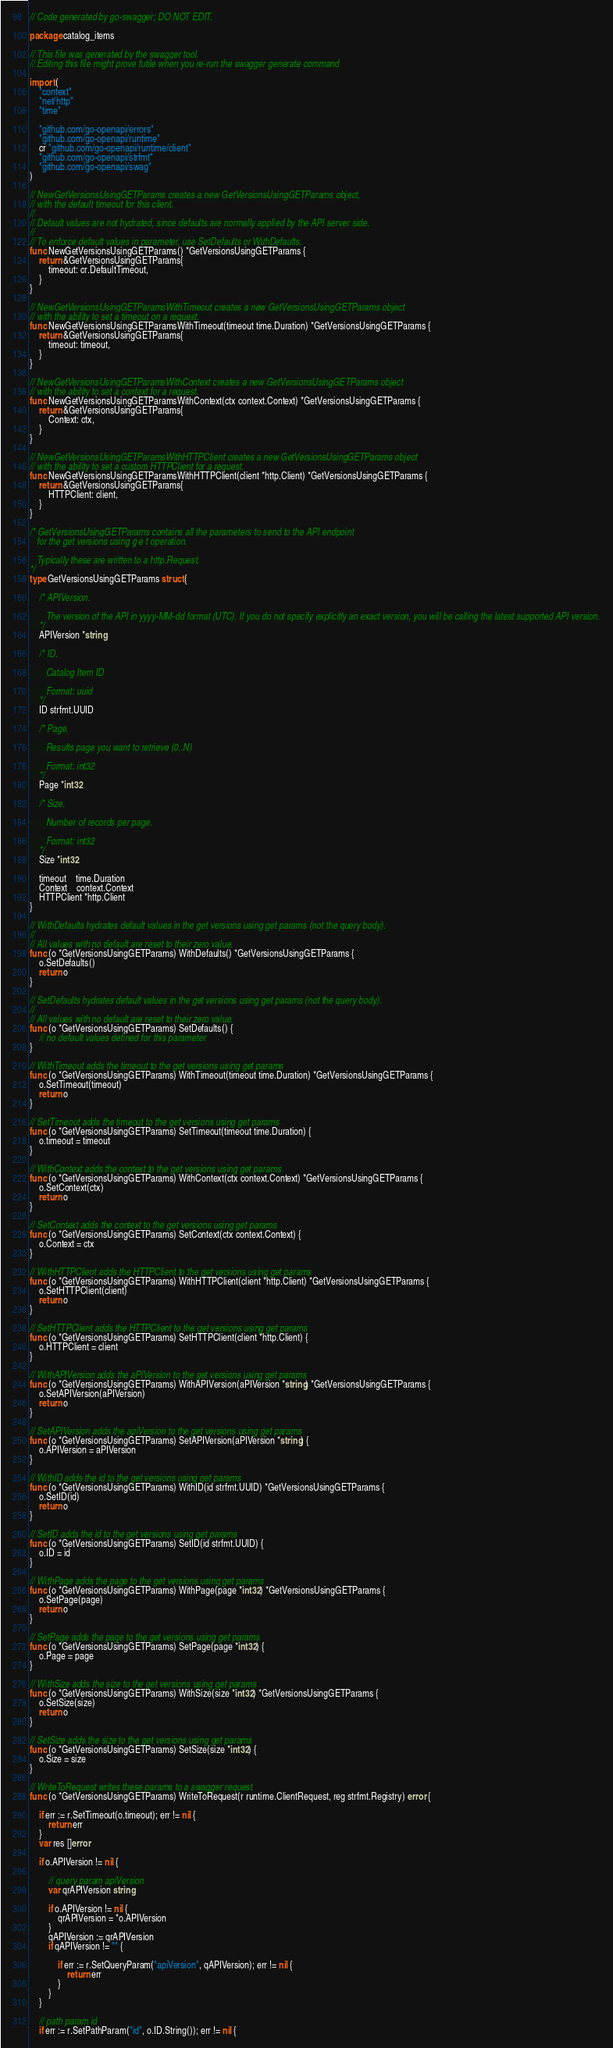<code> <loc_0><loc_0><loc_500><loc_500><_Go_>// Code generated by go-swagger; DO NOT EDIT.

package catalog_items

// This file was generated by the swagger tool.
// Editing this file might prove futile when you re-run the swagger generate command

import (
	"context"
	"net/http"
	"time"

	"github.com/go-openapi/errors"
	"github.com/go-openapi/runtime"
	cr "github.com/go-openapi/runtime/client"
	"github.com/go-openapi/strfmt"
	"github.com/go-openapi/swag"
)

// NewGetVersionsUsingGETParams creates a new GetVersionsUsingGETParams object,
// with the default timeout for this client.
//
// Default values are not hydrated, since defaults are normally applied by the API server side.
//
// To enforce default values in parameter, use SetDefaults or WithDefaults.
func NewGetVersionsUsingGETParams() *GetVersionsUsingGETParams {
	return &GetVersionsUsingGETParams{
		timeout: cr.DefaultTimeout,
	}
}

// NewGetVersionsUsingGETParamsWithTimeout creates a new GetVersionsUsingGETParams object
// with the ability to set a timeout on a request.
func NewGetVersionsUsingGETParamsWithTimeout(timeout time.Duration) *GetVersionsUsingGETParams {
	return &GetVersionsUsingGETParams{
		timeout: timeout,
	}
}

// NewGetVersionsUsingGETParamsWithContext creates a new GetVersionsUsingGETParams object
// with the ability to set a context for a request.
func NewGetVersionsUsingGETParamsWithContext(ctx context.Context) *GetVersionsUsingGETParams {
	return &GetVersionsUsingGETParams{
		Context: ctx,
	}
}

// NewGetVersionsUsingGETParamsWithHTTPClient creates a new GetVersionsUsingGETParams object
// with the ability to set a custom HTTPClient for a request.
func NewGetVersionsUsingGETParamsWithHTTPClient(client *http.Client) *GetVersionsUsingGETParams {
	return &GetVersionsUsingGETParams{
		HTTPClient: client,
	}
}

/* GetVersionsUsingGETParams contains all the parameters to send to the API endpoint
   for the get versions using g e t operation.

   Typically these are written to a http.Request.
*/
type GetVersionsUsingGETParams struct {

	/* APIVersion.

	   The version of the API in yyyy-MM-dd format (UTC). If you do not specify explicitly an exact version, you will be calling the latest supported API version.
	*/
	APIVersion *string

	/* ID.

	   Catalog Item ID

	   Format: uuid
	*/
	ID strfmt.UUID

	/* Page.

	   Results page you want to retrieve (0..N)

	   Format: int32
	*/
	Page *int32

	/* Size.

	   Number of records per page.

	   Format: int32
	*/
	Size *int32

	timeout    time.Duration
	Context    context.Context
	HTTPClient *http.Client
}

// WithDefaults hydrates default values in the get versions using get params (not the query body).
//
// All values with no default are reset to their zero value.
func (o *GetVersionsUsingGETParams) WithDefaults() *GetVersionsUsingGETParams {
	o.SetDefaults()
	return o
}

// SetDefaults hydrates default values in the get versions using get params (not the query body).
//
// All values with no default are reset to their zero value.
func (o *GetVersionsUsingGETParams) SetDefaults() {
	// no default values defined for this parameter
}

// WithTimeout adds the timeout to the get versions using get params
func (o *GetVersionsUsingGETParams) WithTimeout(timeout time.Duration) *GetVersionsUsingGETParams {
	o.SetTimeout(timeout)
	return o
}

// SetTimeout adds the timeout to the get versions using get params
func (o *GetVersionsUsingGETParams) SetTimeout(timeout time.Duration) {
	o.timeout = timeout
}

// WithContext adds the context to the get versions using get params
func (o *GetVersionsUsingGETParams) WithContext(ctx context.Context) *GetVersionsUsingGETParams {
	o.SetContext(ctx)
	return o
}

// SetContext adds the context to the get versions using get params
func (o *GetVersionsUsingGETParams) SetContext(ctx context.Context) {
	o.Context = ctx
}

// WithHTTPClient adds the HTTPClient to the get versions using get params
func (o *GetVersionsUsingGETParams) WithHTTPClient(client *http.Client) *GetVersionsUsingGETParams {
	o.SetHTTPClient(client)
	return o
}

// SetHTTPClient adds the HTTPClient to the get versions using get params
func (o *GetVersionsUsingGETParams) SetHTTPClient(client *http.Client) {
	o.HTTPClient = client
}

// WithAPIVersion adds the aPIVersion to the get versions using get params
func (o *GetVersionsUsingGETParams) WithAPIVersion(aPIVersion *string) *GetVersionsUsingGETParams {
	o.SetAPIVersion(aPIVersion)
	return o
}

// SetAPIVersion adds the apiVersion to the get versions using get params
func (o *GetVersionsUsingGETParams) SetAPIVersion(aPIVersion *string) {
	o.APIVersion = aPIVersion
}

// WithID adds the id to the get versions using get params
func (o *GetVersionsUsingGETParams) WithID(id strfmt.UUID) *GetVersionsUsingGETParams {
	o.SetID(id)
	return o
}

// SetID adds the id to the get versions using get params
func (o *GetVersionsUsingGETParams) SetID(id strfmt.UUID) {
	o.ID = id
}

// WithPage adds the page to the get versions using get params
func (o *GetVersionsUsingGETParams) WithPage(page *int32) *GetVersionsUsingGETParams {
	o.SetPage(page)
	return o
}

// SetPage adds the page to the get versions using get params
func (o *GetVersionsUsingGETParams) SetPage(page *int32) {
	o.Page = page
}

// WithSize adds the size to the get versions using get params
func (o *GetVersionsUsingGETParams) WithSize(size *int32) *GetVersionsUsingGETParams {
	o.SetSize(size)
	return o
}

// SetSize adds the size to the get versions using get params
func (o *GetVersionsUsingGETParams) SetSize(size *int32) {
	o.Size = size
}

// WriteToRequest writes these params to a swagger request
func (o *GetVersionsUsingGETParams) WriteToRequest(r runtime.ClientRequest, reg strfmt.Registry) error {

	if err := r.SetTimeout(o.timeout); err != nil {
		return err
	}
	var res []error

	if o.APIVersion != nil {

		// query param apiVersion
		var qrAPIVersion string

		if o.APIVersion != nil {
			qrAPIVersion = *o.APIVersion
		}
		qAPIVersion := qrAPIVersion
		if qAPIVersion != "" {

			if err := r.SetQueryParam("apiVersion", qAPIVersion); err != nil {
				return err
			}
		}
	}

	// path param id
	if err := r.SetPathParam("id", o.ID.String()); err != nil {</code> 